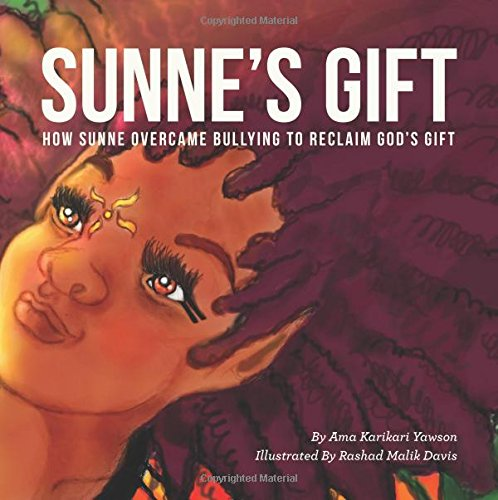Who is the author of this book? The author of the book shown in the image is Ama Karikari Yawson, a known writer who focuses on culturally relevant topics in children's literature. 